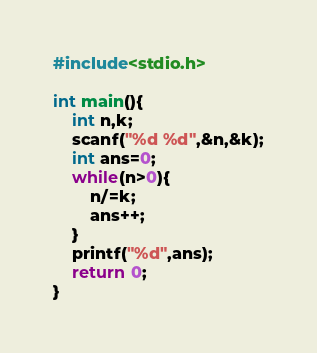Convert code to text. <code><loc_0><loc_0><loc_500><loc_500><_C_>#include<stdio.h>

int main(){
    int n,k;
    scanf("%d %d",&n,&k);
    int ans=0;
    while(n>0){
        n/=k;
        ans++;
    }
    printf("%d",ans);
    return 0;
}</code> 